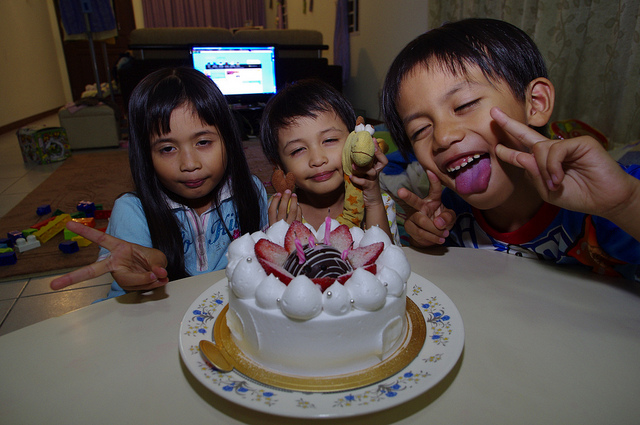Identify the text displayed in this image. Hi 